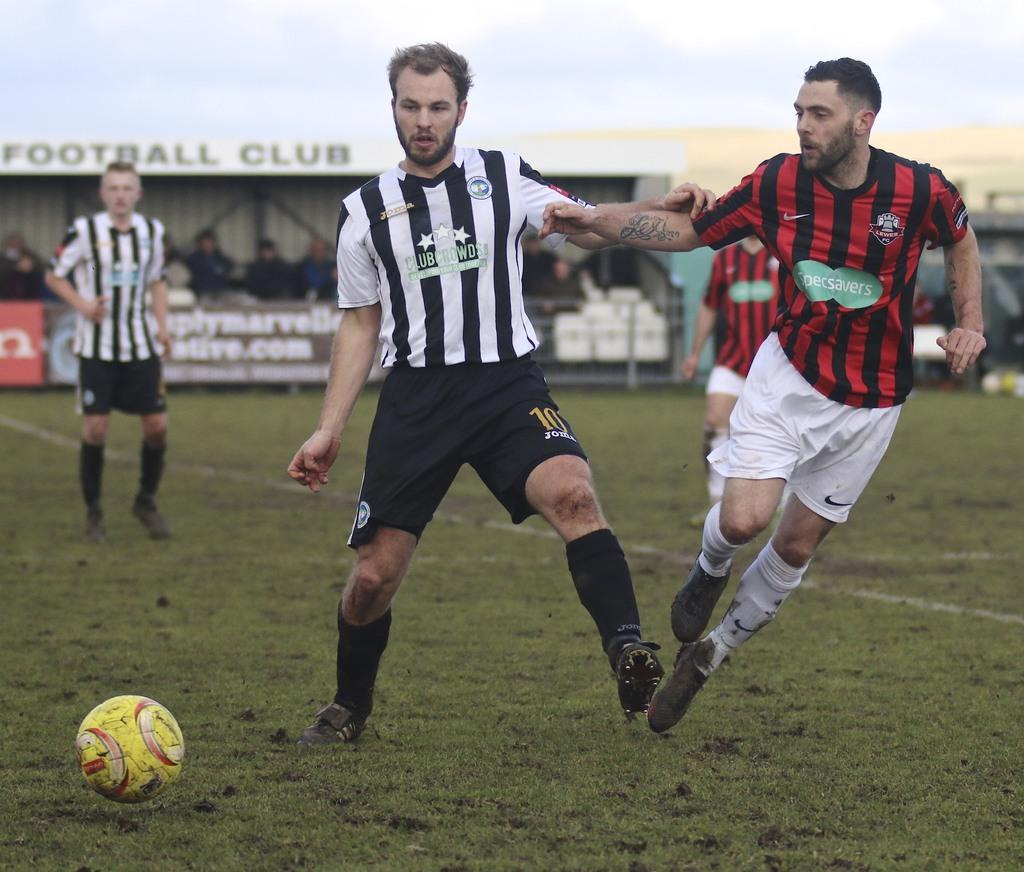<image>
Write a terse but informative summary of the picture. two soccer players race for the ball with one from the Specsavers team 